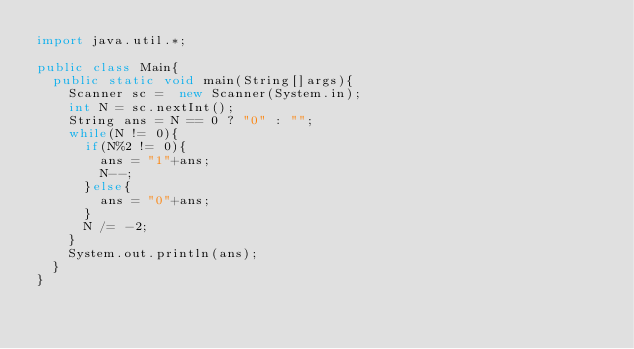<code> <loc_0><loc_0><loc_500><loc_500><_Java_>import java.util.*;
 
public class Main{
  public static void main(String[]args){
    Scanner sc =  new Scanner(System.in);
    int N = sc.nextInt();
    String ans = N == 0 ? "0" : "";
    while(N != 0){
      if(N%2 != 0){
        ans = "1"+ans;
        N--;
      }else{
        ans = "0"+ans;
      }
      N /= -2;
    }
    System.out.println(ans);
  }
}</code> 